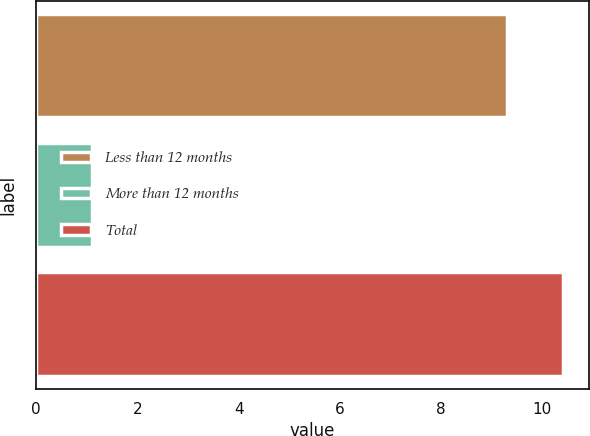Convert chart to OTSL. <chart><loc_0><loc_0><loc_500><loc_500><bar_chart><fcel>Less than 12 months<fcel>More than 12 months<fcel>Total<nl><fcel>9.3<fcel>1.1<fcel>10.4<nl></chart> 